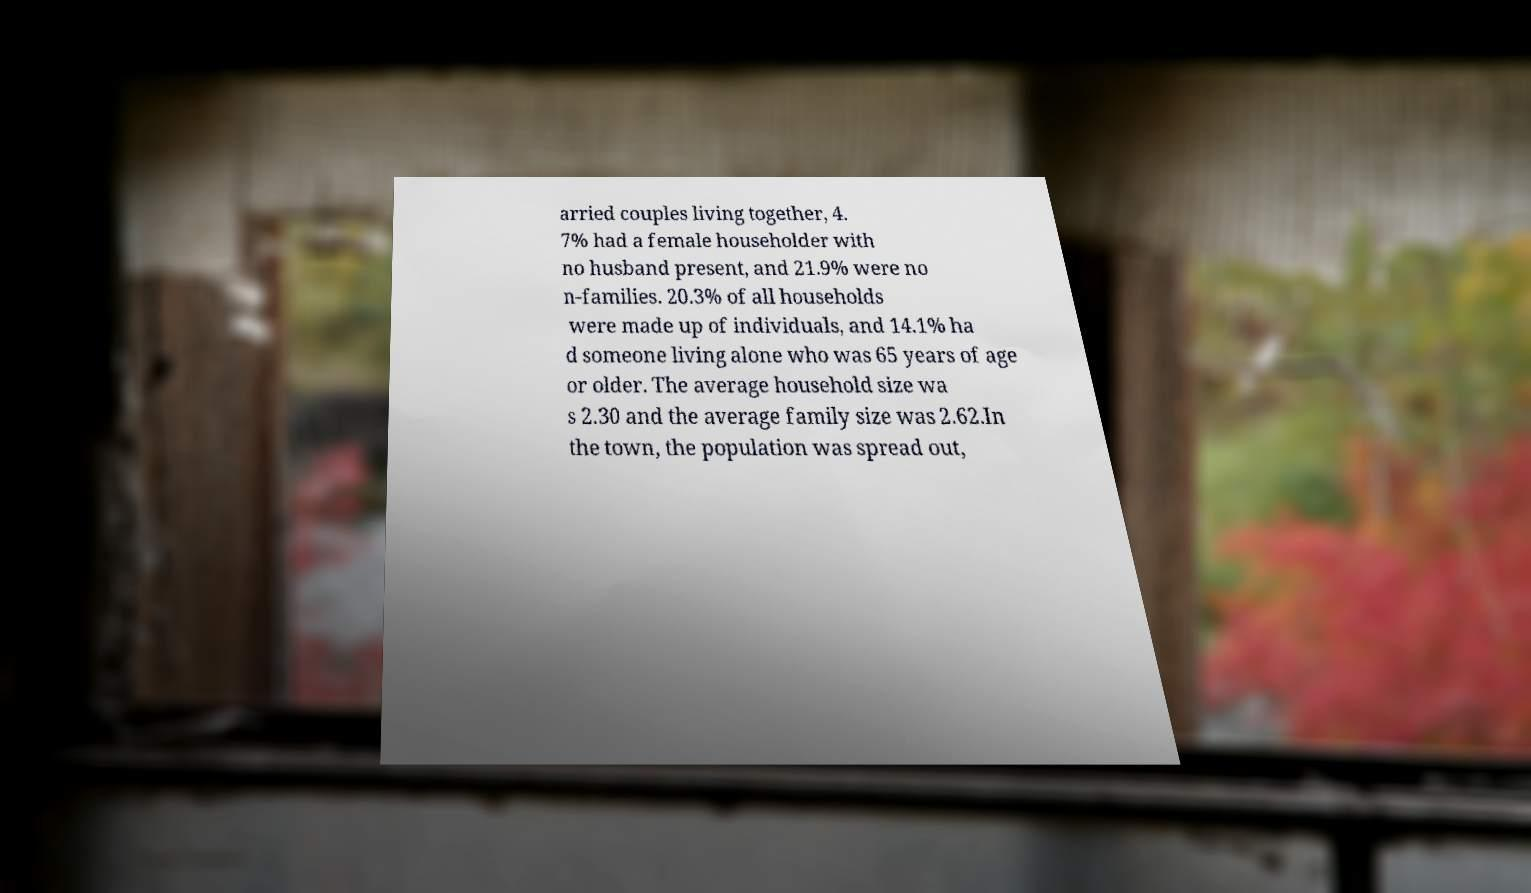Can you read and provide the text displayed in the image?This photo seems to have some interesting text. Can you extract and type it out for me? arried couples living together, 4. 7% had a female householder with no husband present, and 21.9% were no n-families. 20.3% of all households were made up of individuals, and 14.1% ha d someone living alone who was 65 years of age or older. The average household size wa s 2.30 and the average family size was 2.62.In the town, the population was spread out, 